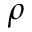<formula> <loc_0><loc_0><loc_500><loc_500>\rho</formula> 